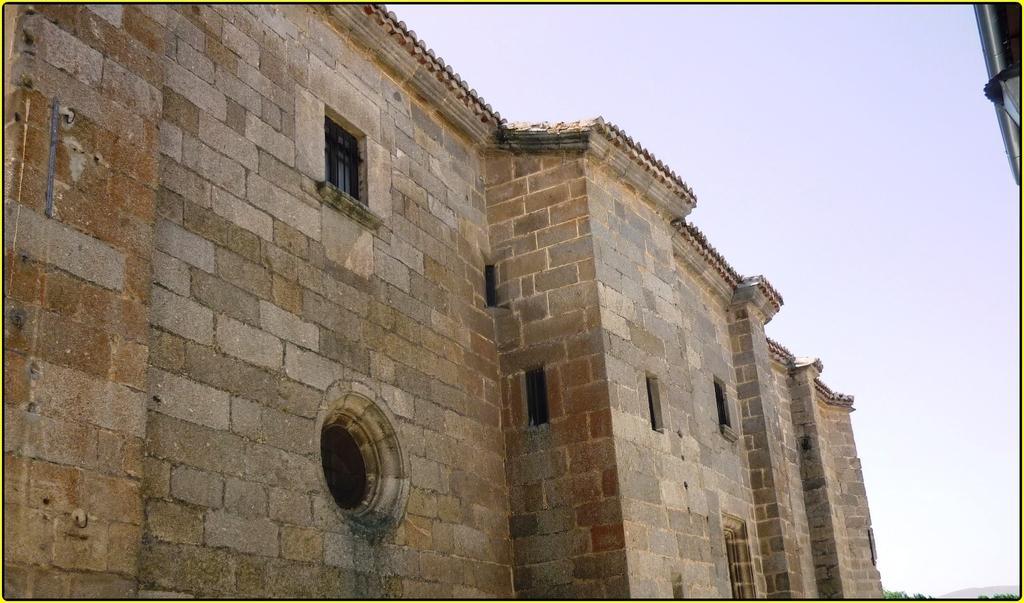How would you summarize this image in a sentence or two? In this picture we can see a building with windows, leaves and in the background we can see the sky. 